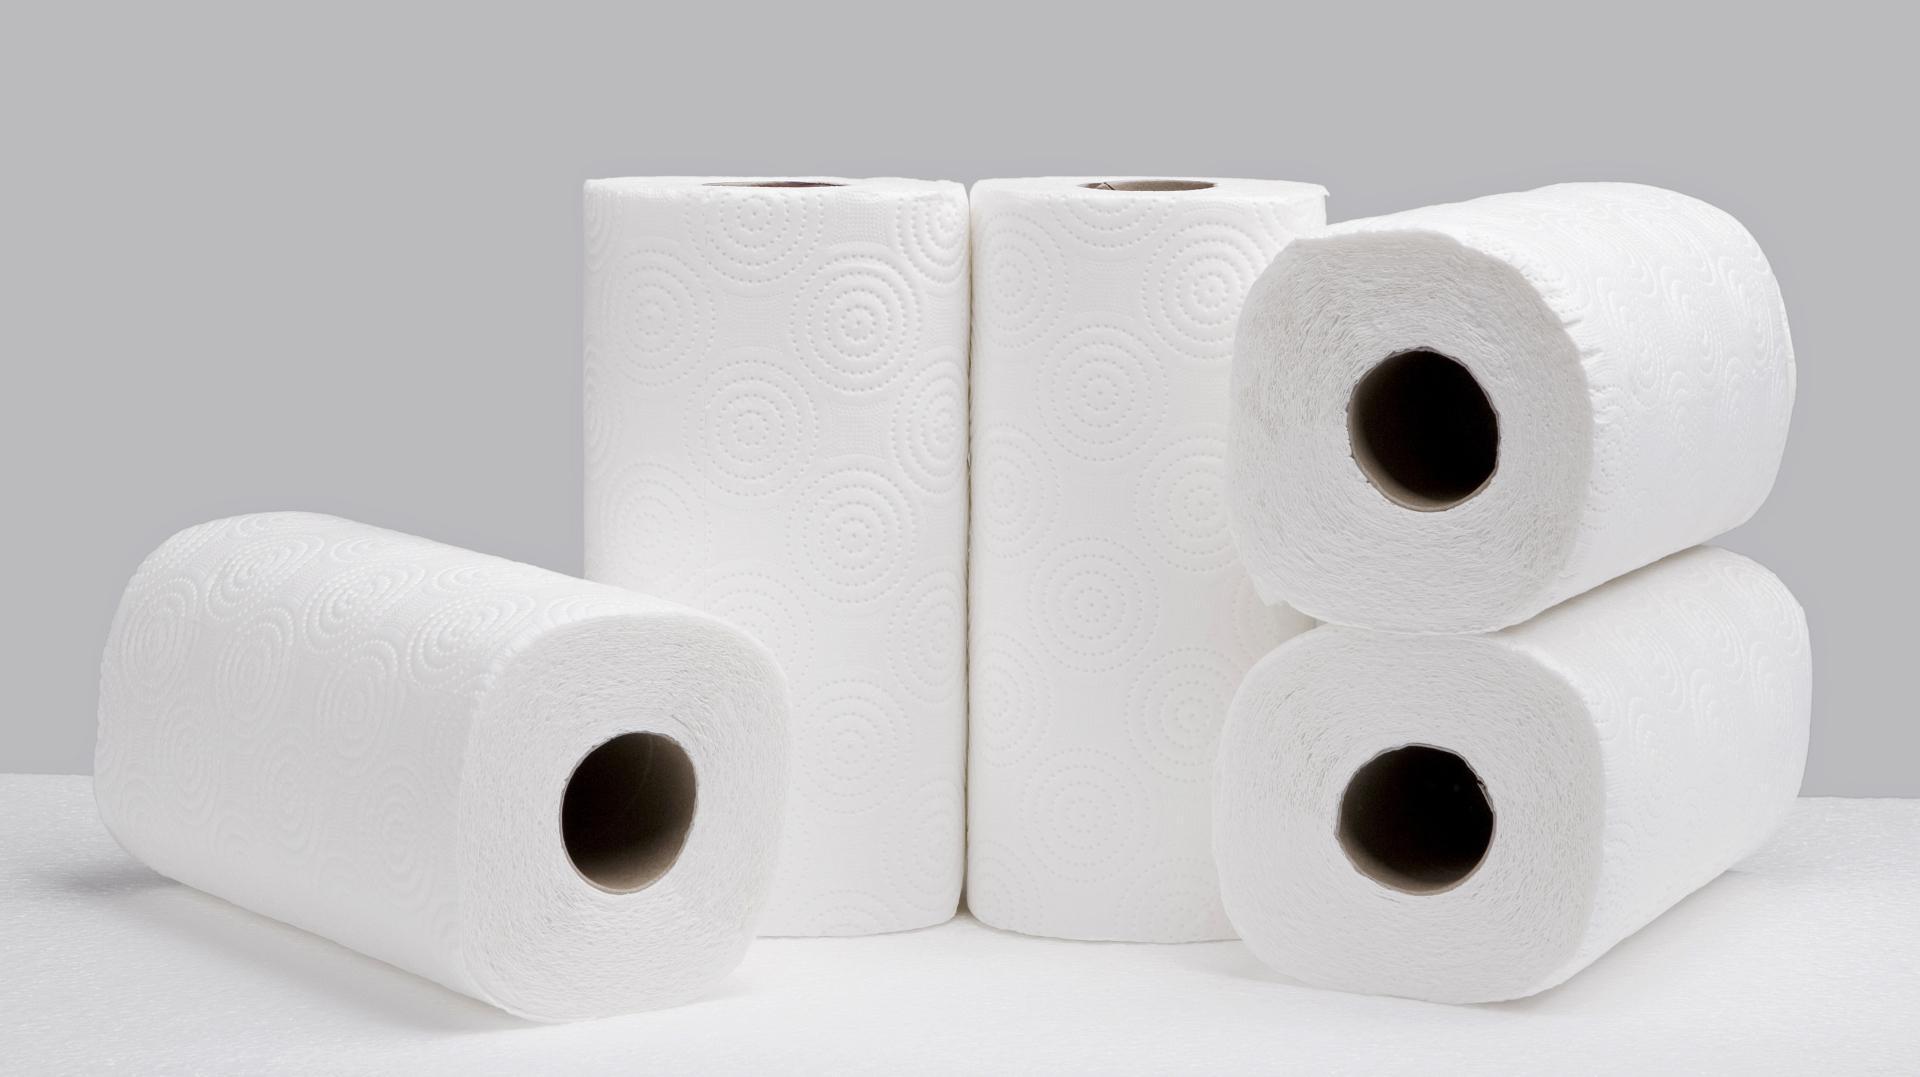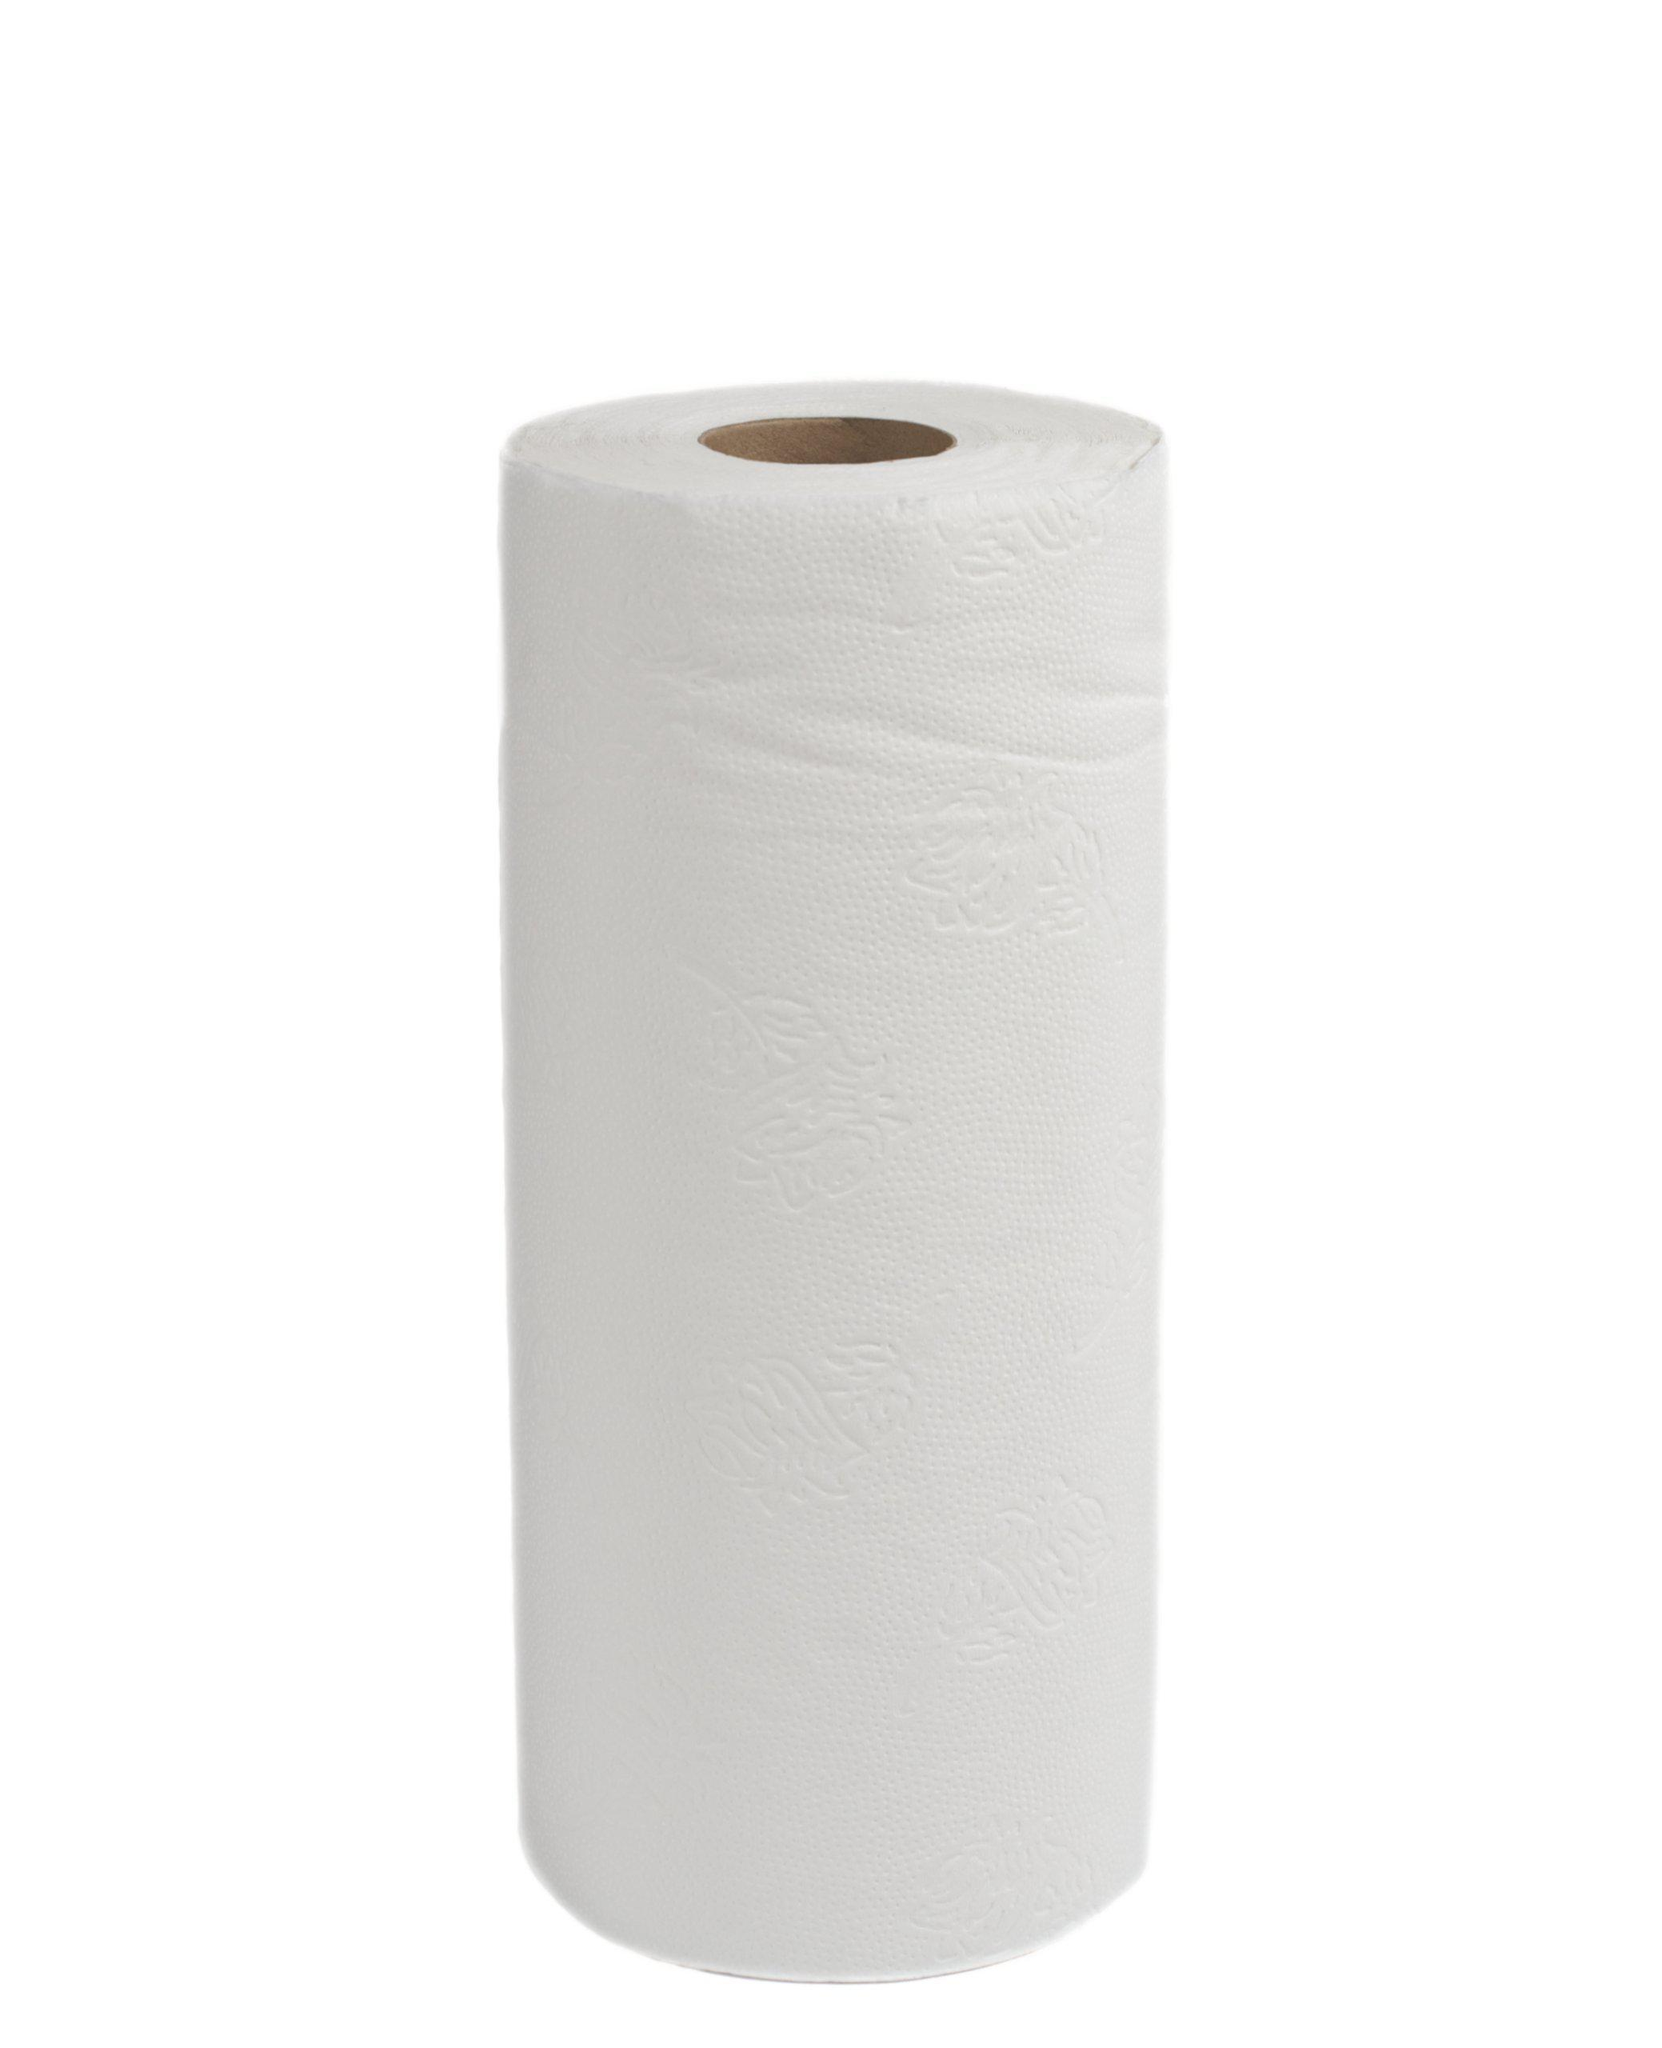The first image is the image on the left, the second image is the image on the right. Evaluate the accuracy of this statement regarding the images: "There are three rolls of paper". Is it true? Answer yes or no. No. The first image is the image on the left, the second image is the image on the right. Assess this claim about the two images: "One image shows exactly one roll standing in front of a roll laying on its side.". Correct or not? Answer yes or no. No. 